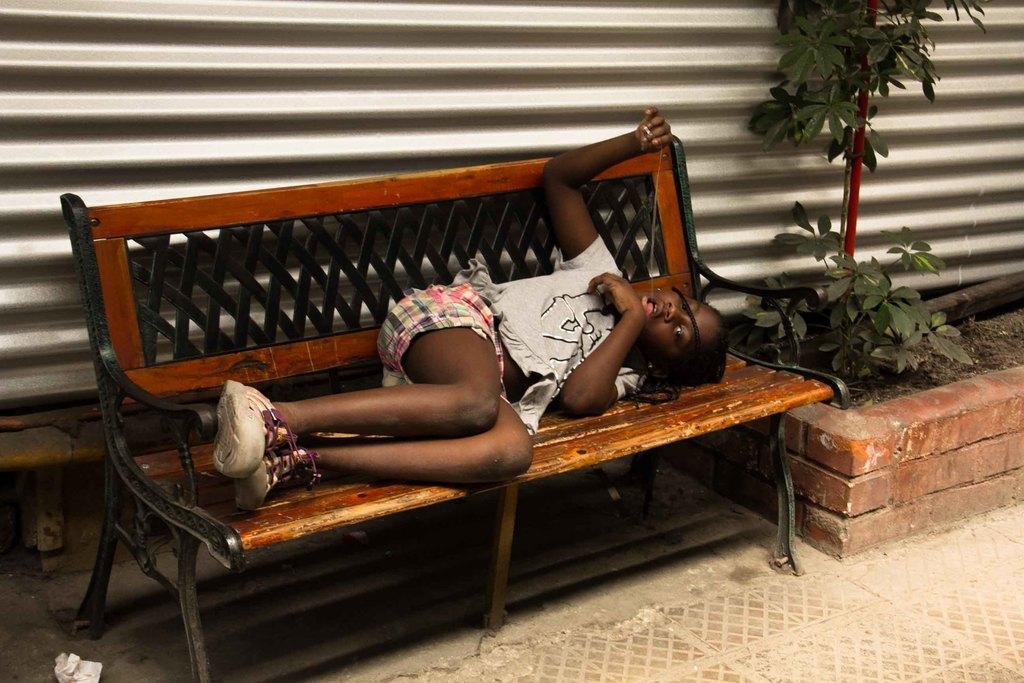In one or two sentences, can you explain what this image depicts? In this image there is a girl sleeping on the bench. Behind the bench there is a sweater. On the right side there is a plant. 